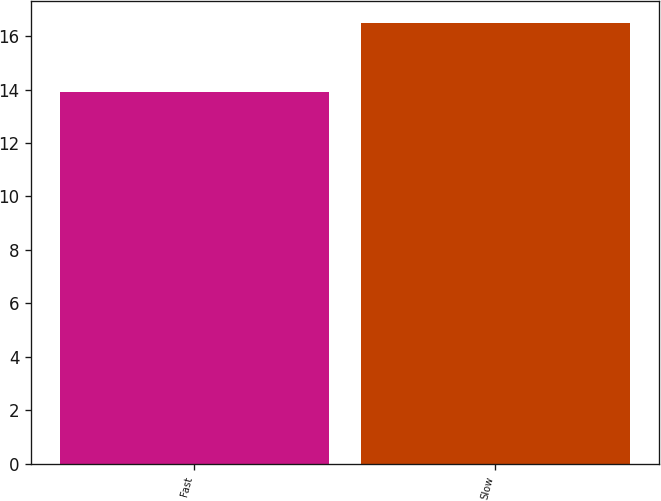<chart> <loc_0><loc_0><loc_500><loc_500><bar_chart><fcel>Fast<fcel>Slow<nl><fcel>13.9<fcel>16.5<nl></chart> 